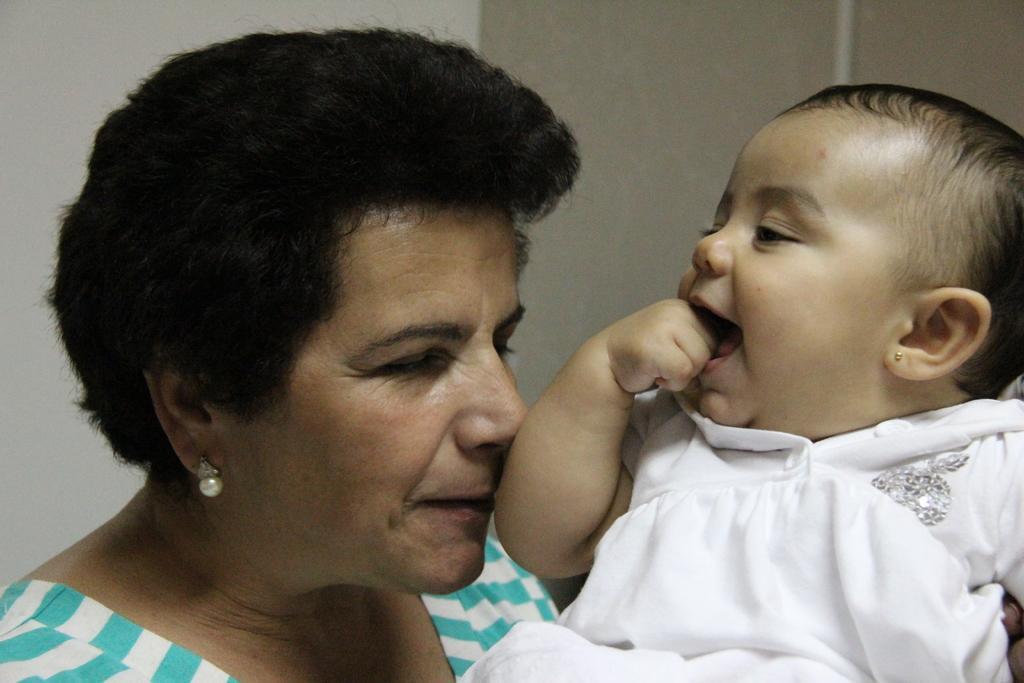Please provide a concise description of this image. In this image I can see a woman and a baby. I can see this baby is wearing white colour dress and here I can see she is wearing a top which is in blue and white colour. 